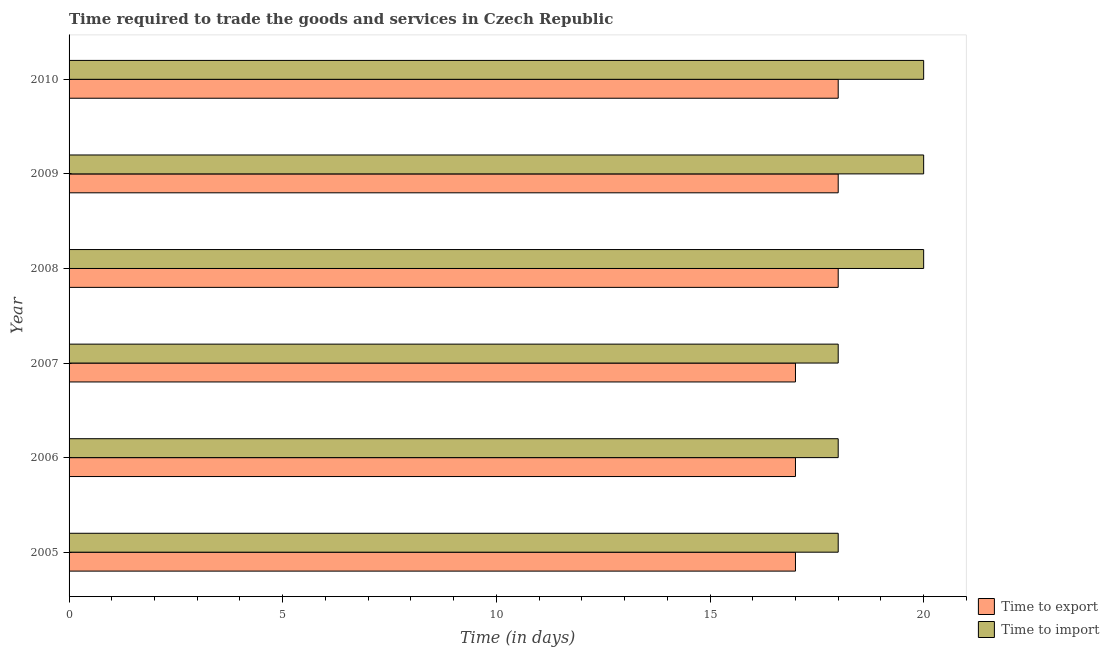How many different coloured bars are there?
Your answer should be compact. 2. How many groups of bars are there?
Offer a very short reply. 6. Are the number of bars on each tick of the Y-axis equal?
Provide a short and direct response. Yes. How many bars are there on the 2nd tick from the top?
Ensure brevity in your answer.  2. What is the label of the 6th group of bars from the top?
Your answer should be compact. 2005. In how many cases, is the number of bars for a given year not equal to the number of legend labels?
Give a very brief answer. 0. What is the time to import in 2010?
Make the answer very short. 20. Across all years, what is the maximum time to export?
Make the answer very short. 18. Across all years, what is the minimum time to import?
Offer a terse response. 18. In which year was the time to export maximum?
Offer a terse response. 2008. In which year was the time to import minimum?
Ensure brevity in your answer.  2005. What is the total time to export in the graph?
Keep it short and to the point. 105. What is the difference between the time to import in 2008 and that in 2009?
Your response must be concise. 0. What is the average time to import per year?
Give a very brief answer. 19. In the year 2007, what is the difference between the time to import and time to export?
Offer a very short reply. 1. What is the ratio of the time to import in 2007 to that in 2009?
Your answer should be compact. 0.9. Is the time to export in 2008 less than that in 2009?
Your answer should be very brief. No. Is the difference between the time to import in 2006 and 2007 greater than the difference between the time to export in 2006 and 2007?
Your response must be concise. No. What is the difference between the highest and the second highest time to import?
Give a very brief answer. 0. What is the difference between the highest and the lowest time to import?
Provide a succinct answer. 2. Is the sum of the time to export in 2005 and 2006 greater than the maximum time to import across all years?
Keep it short and to the point. Yes. What does the 2nd bar from the top in 2010 represents?
Give a very brief answer. Time to export. What does the 1st bar from the bottom in 2009 represents?
Make the answer very short. Time to export. How many bars are there?
Keep it short and to the point. 12. What is the difference between two consecutive major ticks on the X-axis?
Provide a short and direct response. 5. Are the values on the major ticks of X-axis written in scientific E-notation?
Make the answer very short. No. Does the graph contain grids?
Your answer should be compact. No. Where does the legend appear in the graph?
Your response must be concise. Bottom right. What is the title of the graph?
Keep it short and to the point. Time required to trade the goods and services in Czech Republic. What is the label or title of the X-axis?
Give a very brief answer. Time (in days). What is the Time (in days) of Time to export in 2009?
Offer a very short reply. 18. What is the Time (in days) of Time to import in 2009?
Offer a terse response. 20. Across all years, what is the maximum Time (in days) of Time to export?
Your answer should be compact. 18. Across all years, what is the minimum Time (in days) of Time to export?
Offer a terse response. 17. Across all years, what is the minimum Time (in days) of Time to import?
Offer a very short reply. 18. What is the total Time (in days) in Time to export in the graph?
Your response must be concise. 105. What is the total Time (in days) in Time to import in the graph?
Give a very brief answer. 114. What is the difference between the Time (in days) of Time to import in 2005 and that in 2007?
Ensure brevity in your answer.  0. What is the difference between the Time (in days) in Time to export in 2005 and that in 2008?
Your answer should be very brief. -1. What is the difference between the Time (in days) in Time to export in 2005 and that in 2010?
Make the answer very short. -1. What is the difference between the Time (in days) in Time to import in 2005 and that in 2010?
Keep it short and to the point. -2. What is the difference between the Time (in days) in Time to import in 2006 and that in 2007?
Your response must be concise. 0. What is the difference between the Time (in days) in Time to export in 2006 and that in 2008?
Ensure brevity in your answer.  -1. What is the difference between the Time (in days) of Time to export in 2006 and that in 2009?
Give a very brief answer. -1. What is the difference between the Time (in days) of Time to import in 2006 and that in 2009?
Make the answer very short. -2. What is the difference between the Time (in days) in Time to export in 2006 and that in 2010?
Offer a terse response. -1. What is the difference between the Time (in days) in Time to export in 2007 and that in 2008?
Provide a succinct answer. -1. What is the difference between the Time (in days) in Time to import in 2007 and that in 2008?
Give a very brief answer. -2. What is the difference between the Time (in days) in Time to export in 2007 and that in 2010?
Offer a very short reply. -1. What is the difference between the Time (in days) in Time to export in 2008 and that in 2009?
Your answer should be very brief. 0. What is the difference between the Time (in days) in Time to export in 2008 and that in 2010?
Provide a short and direct response. 0. What is the difference between the Time (in days) of Time to export in 2009 and that in 2010?
Offer a very short reply. 0. What is the difference between the Time (in days) in Time to import in 2009 and that in 2010?
Your answer should be very brief. 0. What is the difference between the Time (in days) of Time to export in 2005 and the Time (in days) of Time to import in 2006?
Your answer should be very brief. -1. What is the difference between the Time (in days) of Time to export in 2005 and the Time (in days) of Time to import in 2008?
Your answer should be compact. -3. What is the difference between the Time (in days) in Time to export in 2005 and the Time (in days) in Time to import in 2009?
Make the answer very short. -3. What is the difference between the Time (in days) of Time to export in 2005 and the Time (in days) of Time to import in 2010?
Keep it short and to the point. -3. What is the difference between the Time (in days) in Time to export in 2006 and the Time (in days) in Time to import in 2007?
Your response must be concise. -1. What is the difference between the Time (in days) of Time to export in 2006 and the Time (in days) of Time to import in 2009?
Provide a succinct answer. -3. What is the difference between the Time (in days) of Time to export in 2006 and the Time (in days) of Time to import in 2010?
Ensure brevity in your answer.  -3. What is the difference between the Time (in days) in Time to export in 2007 and the Time (in days) in Time to import in 2008?
Offer a very short reply. -3. What is the difference between the Time (in days) of Time to export in 2009 and the Time (in days) of Time to import in 2010?
Offer a terse response. -2. What is the average Time (in days) in Time to export per year?
Give a very brief answer. 17.5. What is the average Time (in days) of Time to import per year?
Provide a succinct answer. 19. In the year 2007, what is the difference between the Time (in days) of Time to export and Time (in days) of Time to import?
Give a very brief answer. -1. In the year 2008, what is the difference between the Time (in days) in Time to export and Time (in days) in Time to import?
Your answer should be compact. -2. What is the ratio of the Time (in days) in Time to export in 2005 to that in 2006?
Make the answer very short. 1. What is the ratio of the Time (in days) of Time to import in 2005 to that in 2006?
Give a very brief answer. 1. What is the ratio of the Time (in days) in Time to export in 2005 to that in 2008?
Give a very brief answer. 0.94. What is the ratio of the Time (in days) in Time to export in 2005 to that in 2010?
Your response must be concise. 0.94. What is the ratio of the Time (in days) of Time to import in 2005 to that in 2010?
Give a very brief answer. 0.9. What is the ratio of the Time (in days) in Time to export in 2006 to that in 2007?
Provide a short and direct response. 1. What is the ratio of the Time (in days) of Time to export in 2006 to that in 2008?
Ensure brevity in your answer.  0.94. What is the ratio of the Time (in days) in Time to import in 2006 to that in 2008?
Provide a succinct answer. 0.9. What is the ratio of the Time (in days) in Time to import in 2006 to that in 2009?
Your answer should be very brief. 0.9. What is the ratio of the Time (in days) in Time to export in 2006 to that in 2010?
Provide a short and direct response. 0.94. What is the ratio of the Time (in days) of Time to export in 2007 to that in 2009?
Provide a short and direct response. 0.94. What is the ratio of the Time (in days) of Time to export in 2007 to that in 2010?
Make the answer very short. 0.94. What is the ratio of the Time (in days) in Time to import in 2007 to that in 2010?
Provide a succinct answer. 0.9. What is the ratio of the Time (in days) in Time to export in 2008 to that in 2010?
Provide a succinct answer. 1. What is the ratio of the Time (in days) of Time to import in 2008 to that in 2010?
Give a very brief answer. 1. What is the difference between the highest and the lowest Time (in days) of Time to import?
Provide a succinct answer. 2. 